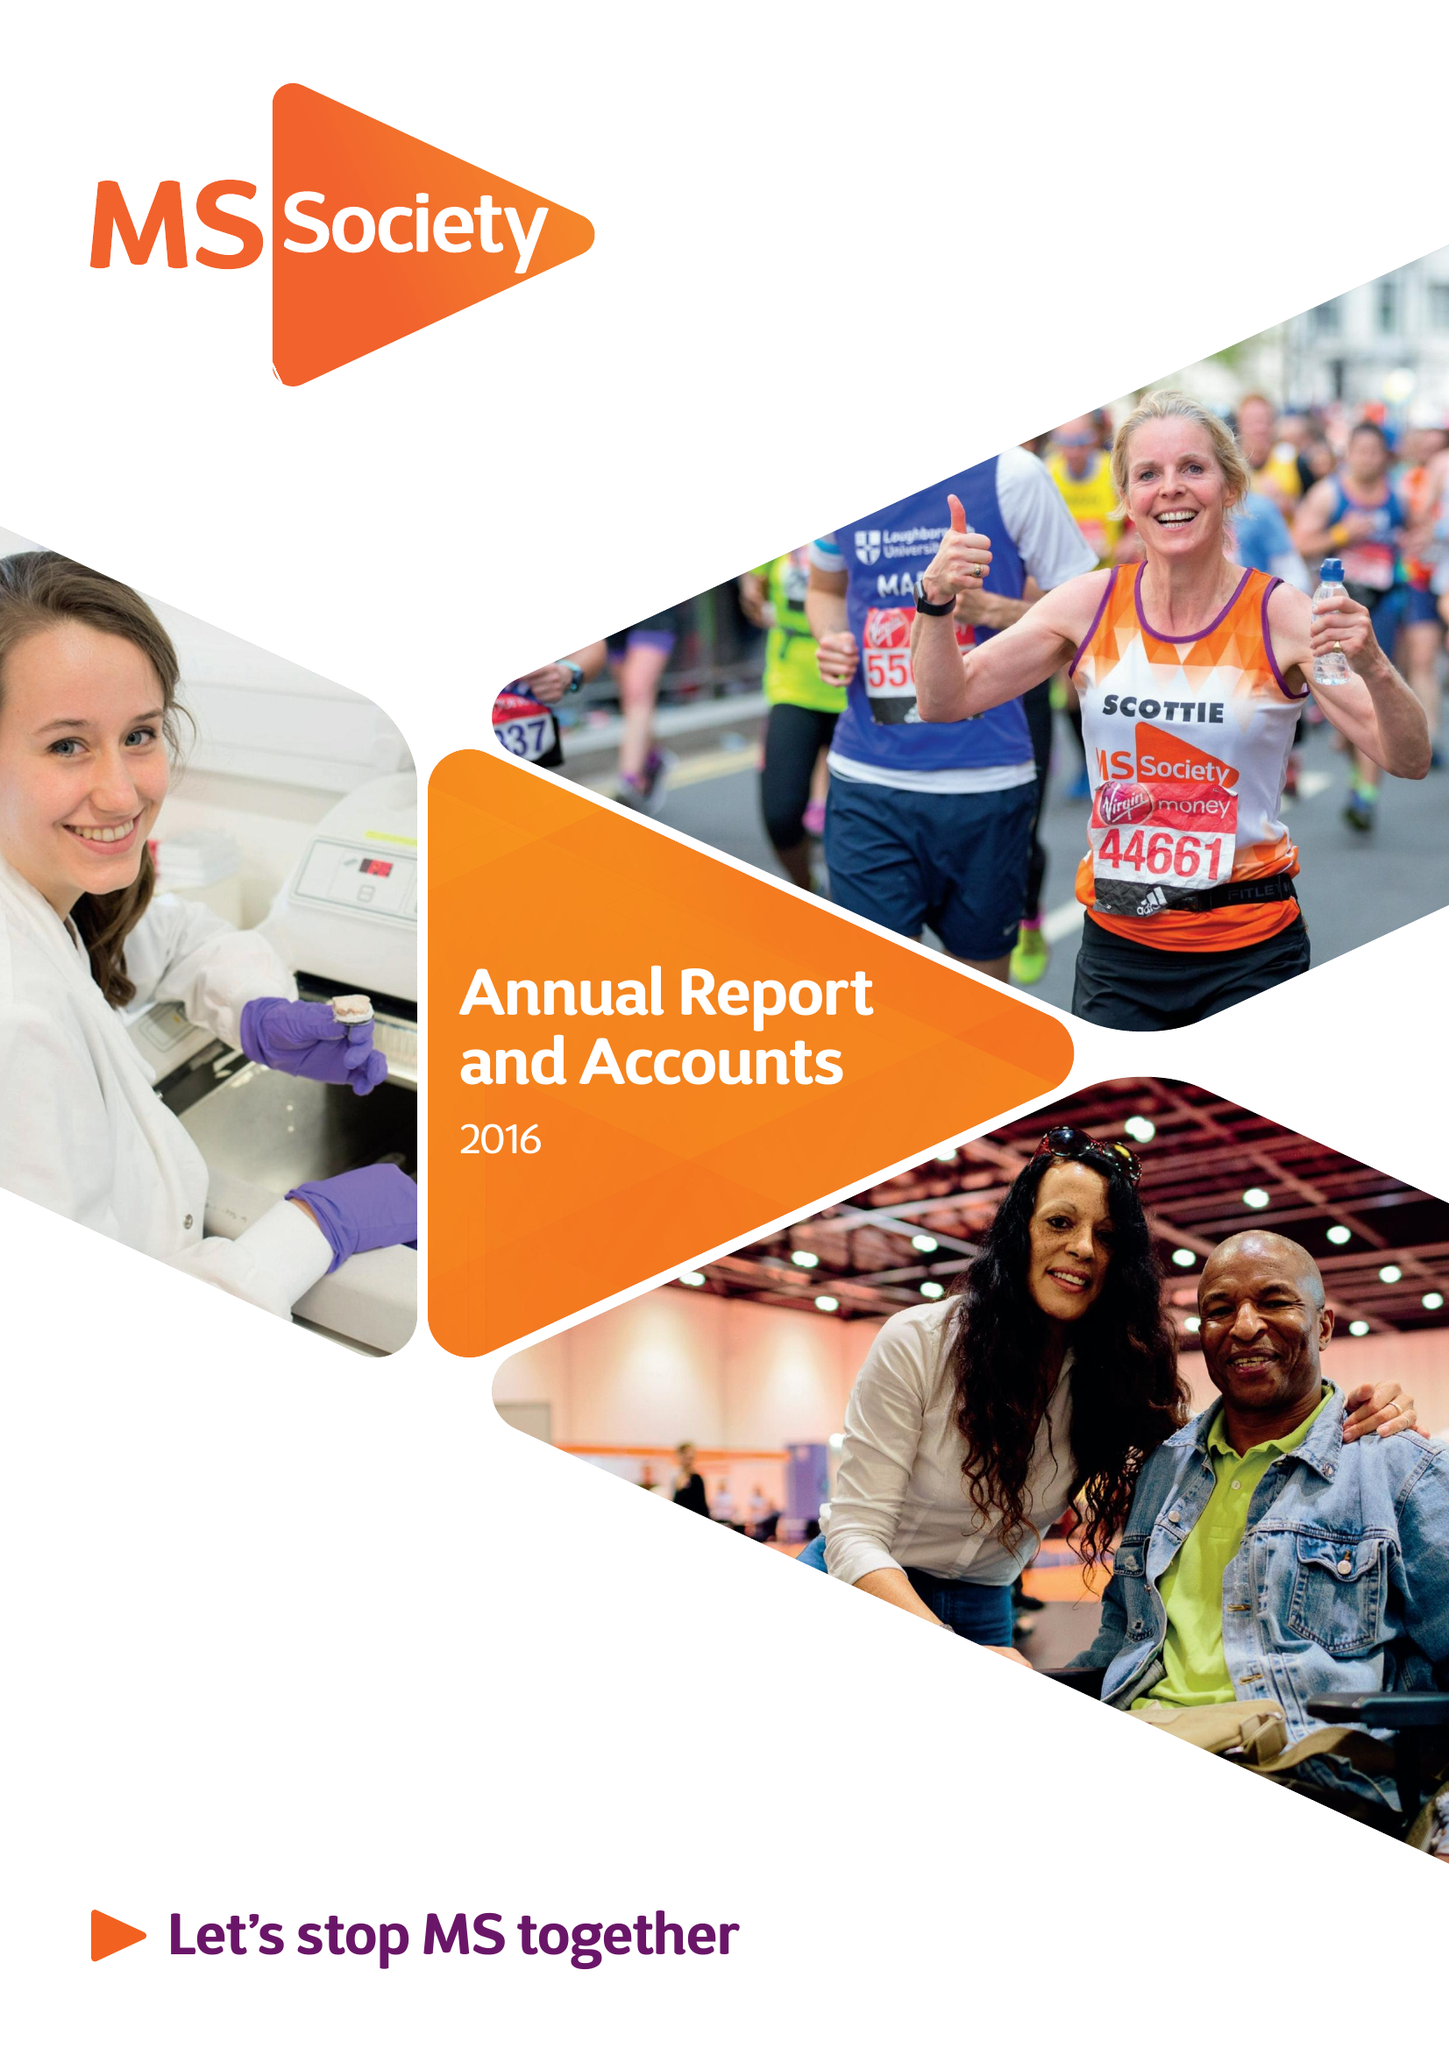What is the value for the income_annually_in_british_pounds?
Answer the question using a single word or phrase. 29023000.00 